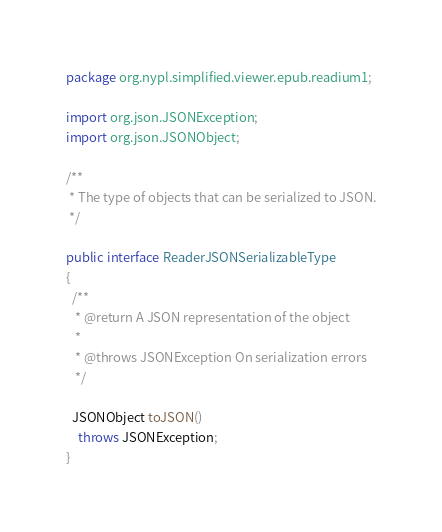<code> <loc_0><loc_0><loc_500><loc_500><_Java_>package org.nypl.simplified.viewer.epub.readium1;

import org.json.JSONException;
import org.json.JSONObject;

/**
 * The type of objects that can be serialized to JSON.
 */

public interface ReaderJSONSerializableType
{
  /**
   * @return A JSON representation of the object
   *
   * @throws JSONException On serialization errors
   */

  JSONObject toJSON()
    throws JSONException;
}
</code> 